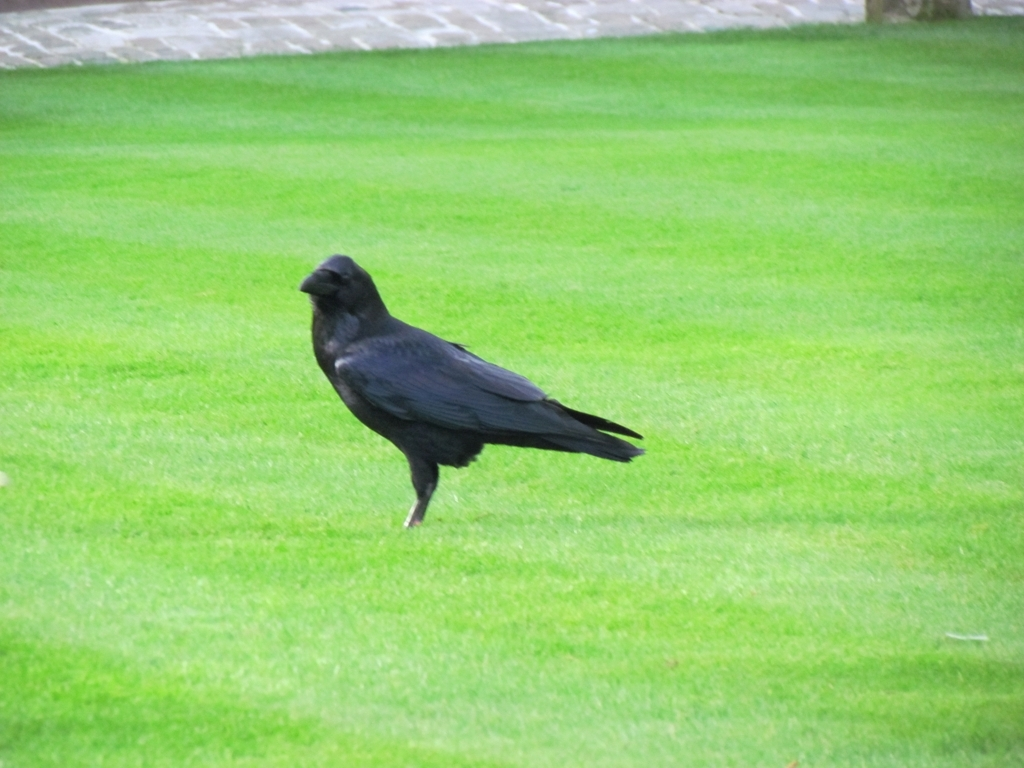Are the colors in the image well-balanced?
A. Washed out
B. Unbalanced
C. Yes The colors in the image are quite natural and show a good contrast between the lush green grass and the dark plumage of the crow, captivating the viewer's attention and contributing to a dynamic visual composition. Option C (Yes) best describes the color balance, as there's no indication that the colors are washed out or unbalanced, but rather they appear quite harmonious within the setting. 